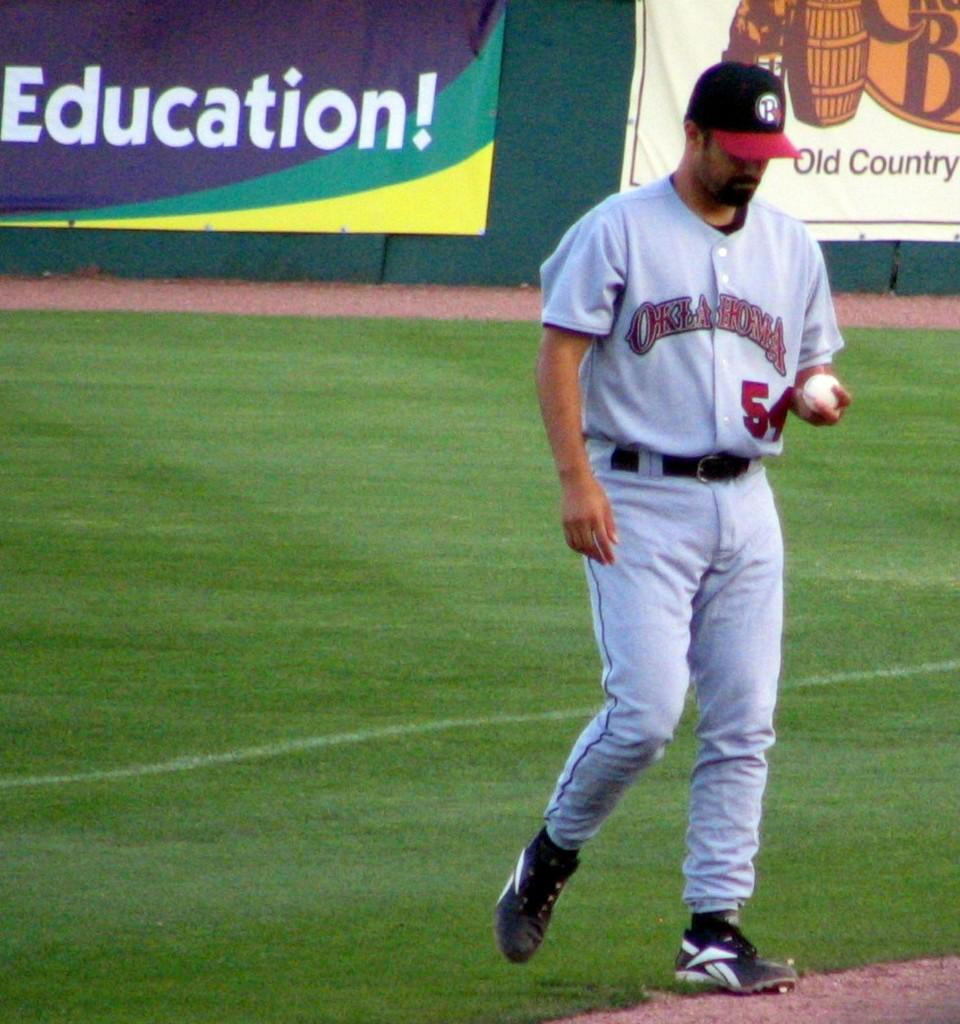<image>
Offer a succinct explanation of the picture presented. Oklahoma baseball player number 54 looks down at the ball he is holding in his hand. 